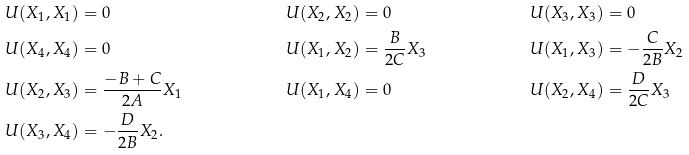Convert formula to latex. <formula><loc_0><loc_0><loc_500><loc_500>& U ( X _ { 1 } , X _ { 1 } ) = 0 & & U ( X _ { 2 } , X _ { 2 } ) = 0 & & U ( X _ { 3 } , X _ { 3 } ) = 0 \\ & U ( X _ { 4 } , X _ { 4 } ) = 0 & & U ( X _ { 1 } , X _ { 2 } ) = \frac { B } { 2 C } X _ { 3 } & & U ( X _ { 1 } , X _ { 3 } ) = - \frac { C } { 2 B } X _ { 2 } \\ & U ( X _ { 2 } , X _ { 3 } ) = \frac { - B + C } { 2 A } X _ { 1 } & & U ( X _ { 1 } , X _ { 4 } ) = 0 & & U ( X _ { 2 } , X _ { 4 } ) = \frac { D } { 2 C } X _ { 3 } \\ & U ( X _ { 3 } , X _ { 4 } ) = - \frac { D } { 2 B } X _ { 2 } . & & & &</formula> 